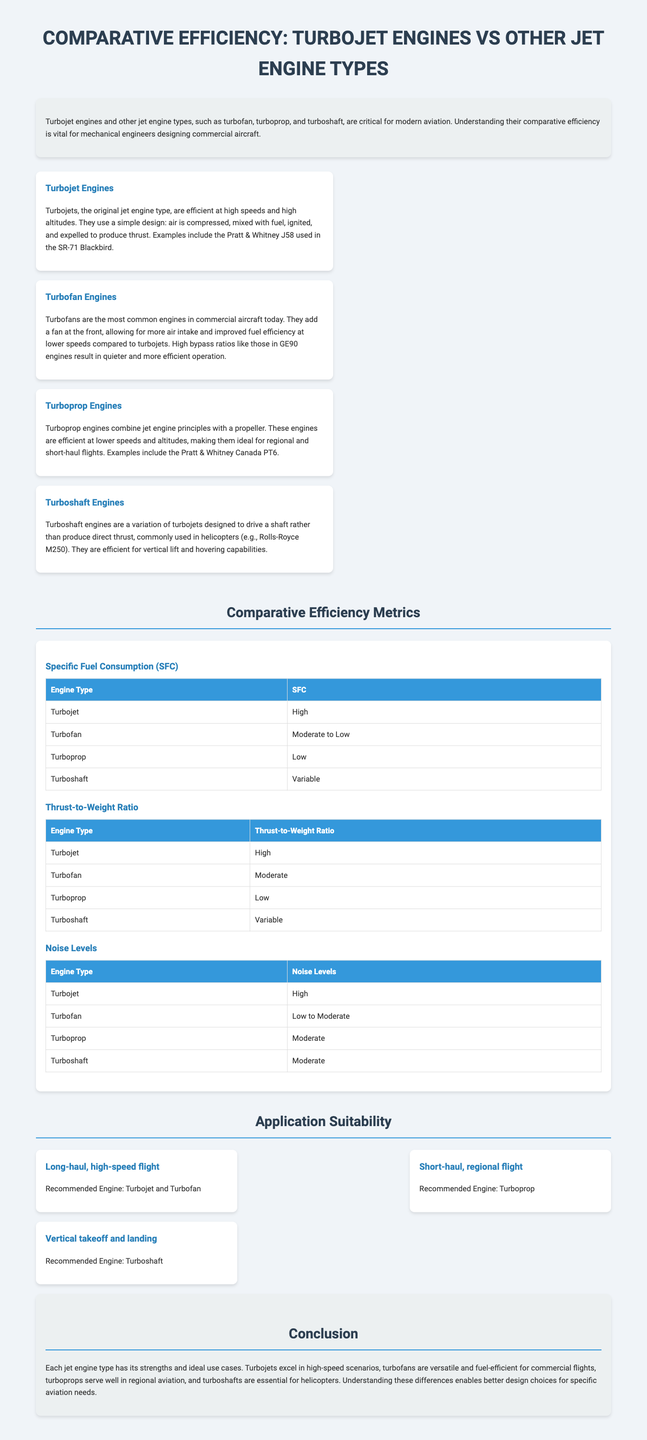What is the most common engine type in commercial aircraft today? The document states that turbofans are the most common engines in commercial aircraft today.
Answer: Turbofan Which engine type is recommended for vertical takeoff and landing? The document indicates that turboshaft engines are recommended for vertical takeoff and landing.
Answer: Turboshaft What is the specific fuel consumption of turbojet engines? The document lists the specific fuel consumption of turbojet engines as high.
Answer: High Which engine type has a moderate to low noise level? According to the document, the turbofan engine has a noise level ranging from low to moderate.
Answer: Turbofan What is the thrust-to-weight ratio for turbojet engines? The document states that turbojet engines have a high thrust-to-weight ratio.
Answer: High Which type of engine is suited for long-haul, high-speed flights? The document mentions that turbojet and turbofan engines are recommended for long-haul, high-speed flights.
Answer: Turbojet and Turbofan What type of engine is used in helicopters? The document specifies that turboshaft engines are commonly used in helicopters.
Answer: Turboshaft What does the document highlight as a characteristic feature of turboprop engines? The document describes turboprop engines as efficient at lower speeds and altitudes.
Answer: Efficient at lower speeds and altitudes Which jet engine type is considered efficient for regional flights? The document states that turboprop engines are ideal for regional and short-haul flights.
Answer: Turboprop 